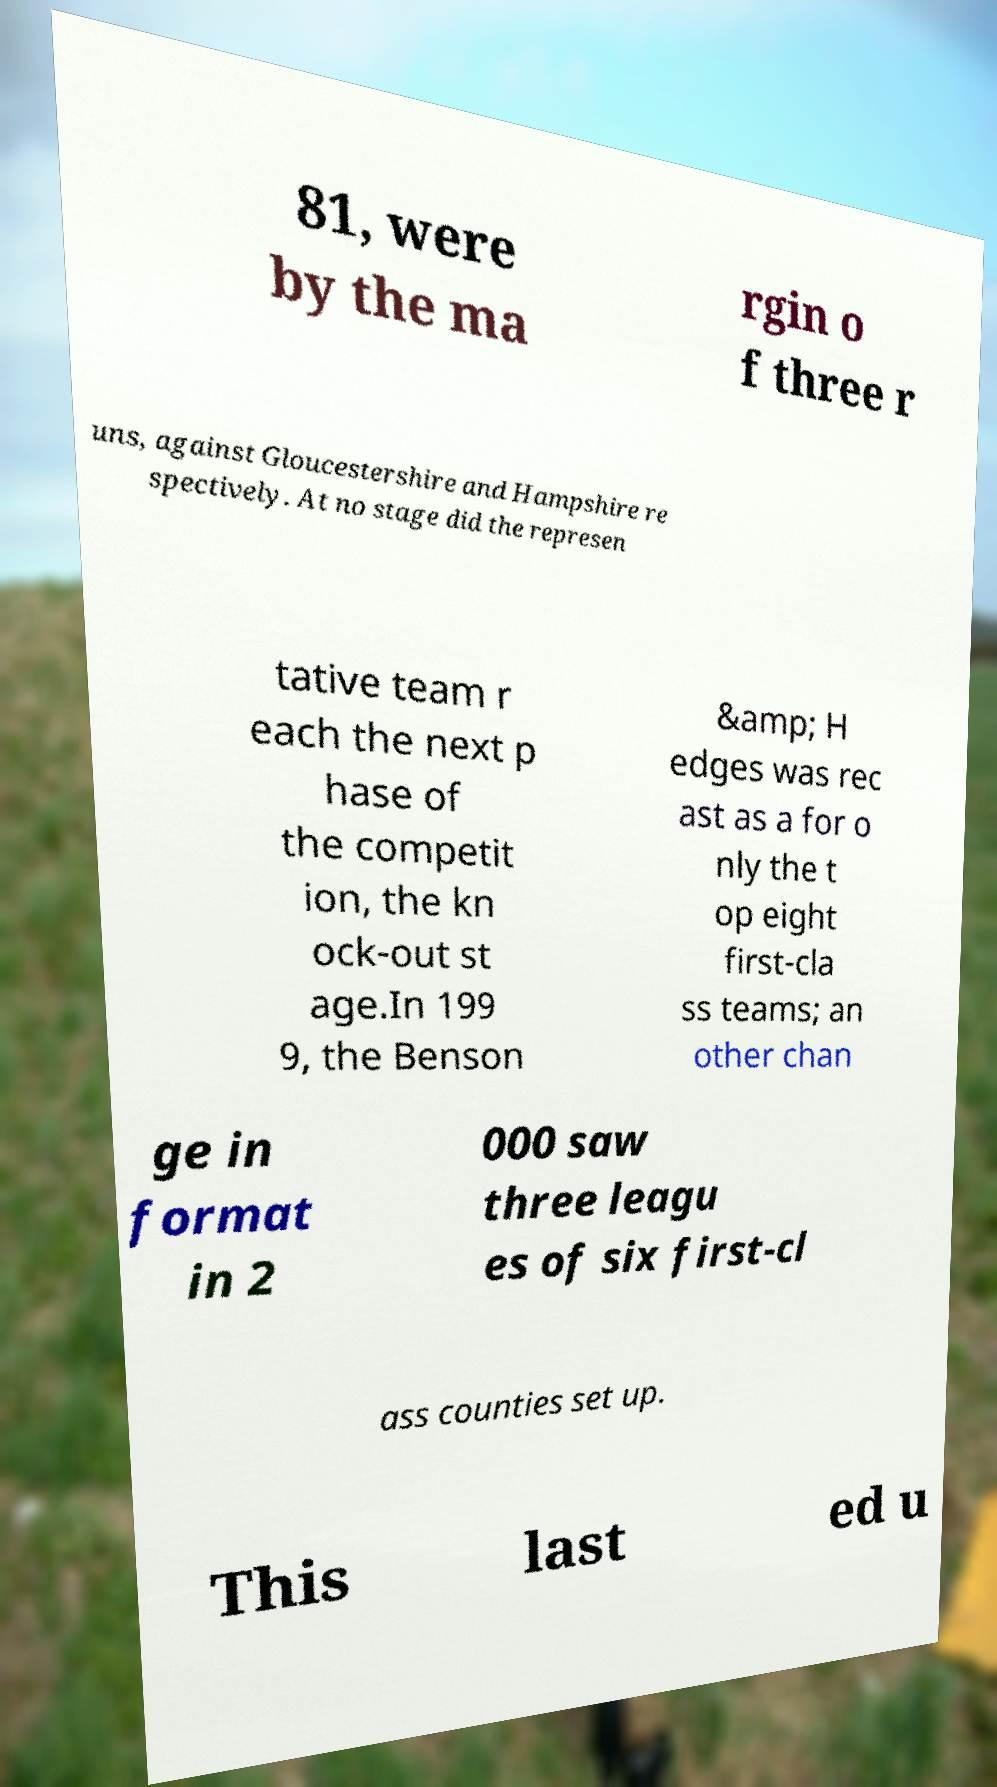Please identify and transcribe the text found in this image. 81, were by the ma rgin o f three r uns, against Gloucestershire and Hampshire re spectively. At no stage did the represen tative team r each the next p hase of the competit ion, the kn ock-out st age.In 199 9, the Benson &amp; H edges was rec ast as a for o nly the t op eight first-cla ss teams; an other chan ge in format in 2 000 saw three leagu es of six first-cl ass counties set up. This last ed u 